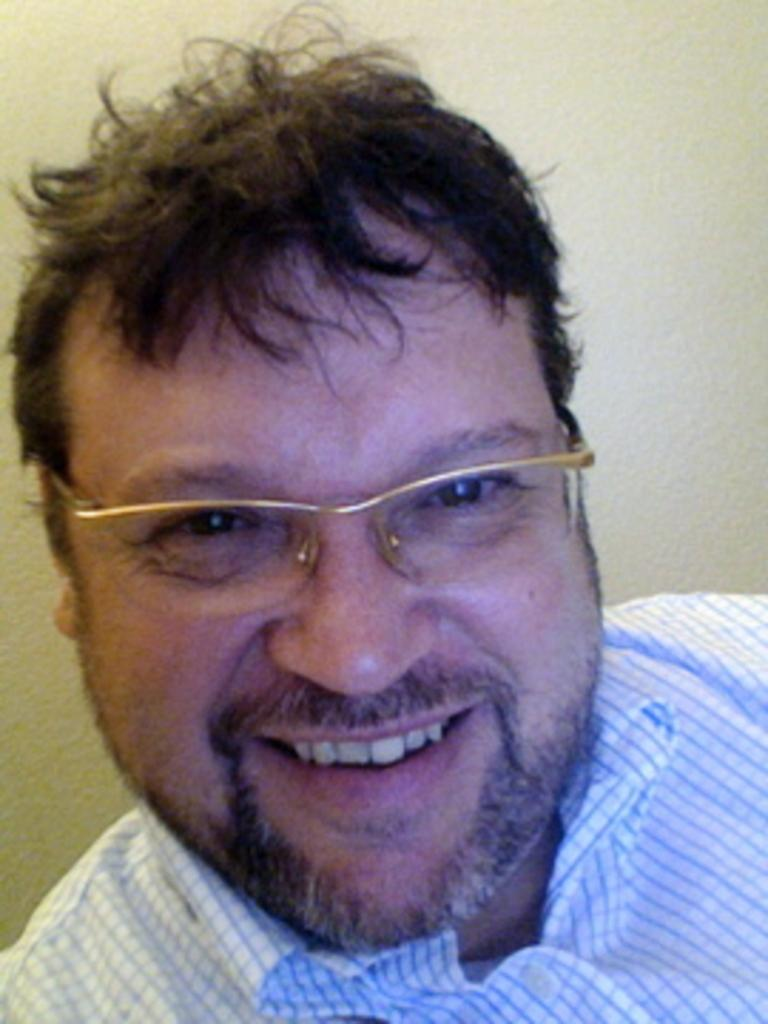Who is present in the image? There is a man in the image. What is the man wearing in the image? The man is wearing a shirt and spectacles in the image. What is the man's facial expression in the image? The man is smiling in the image. What is the man doing in the image? The man is giving a pose for the picture in the image. What can be seen in the background of the image? There is a wall in the background of the image. Can you see the man's mother in the image? There is no mention of the man's mother in the image, so we cannot determine if she is present. Is there a pig in the image? There is no pig present in the image. What type of jelly is the man holding in the image? There is no jelly present in the image. 